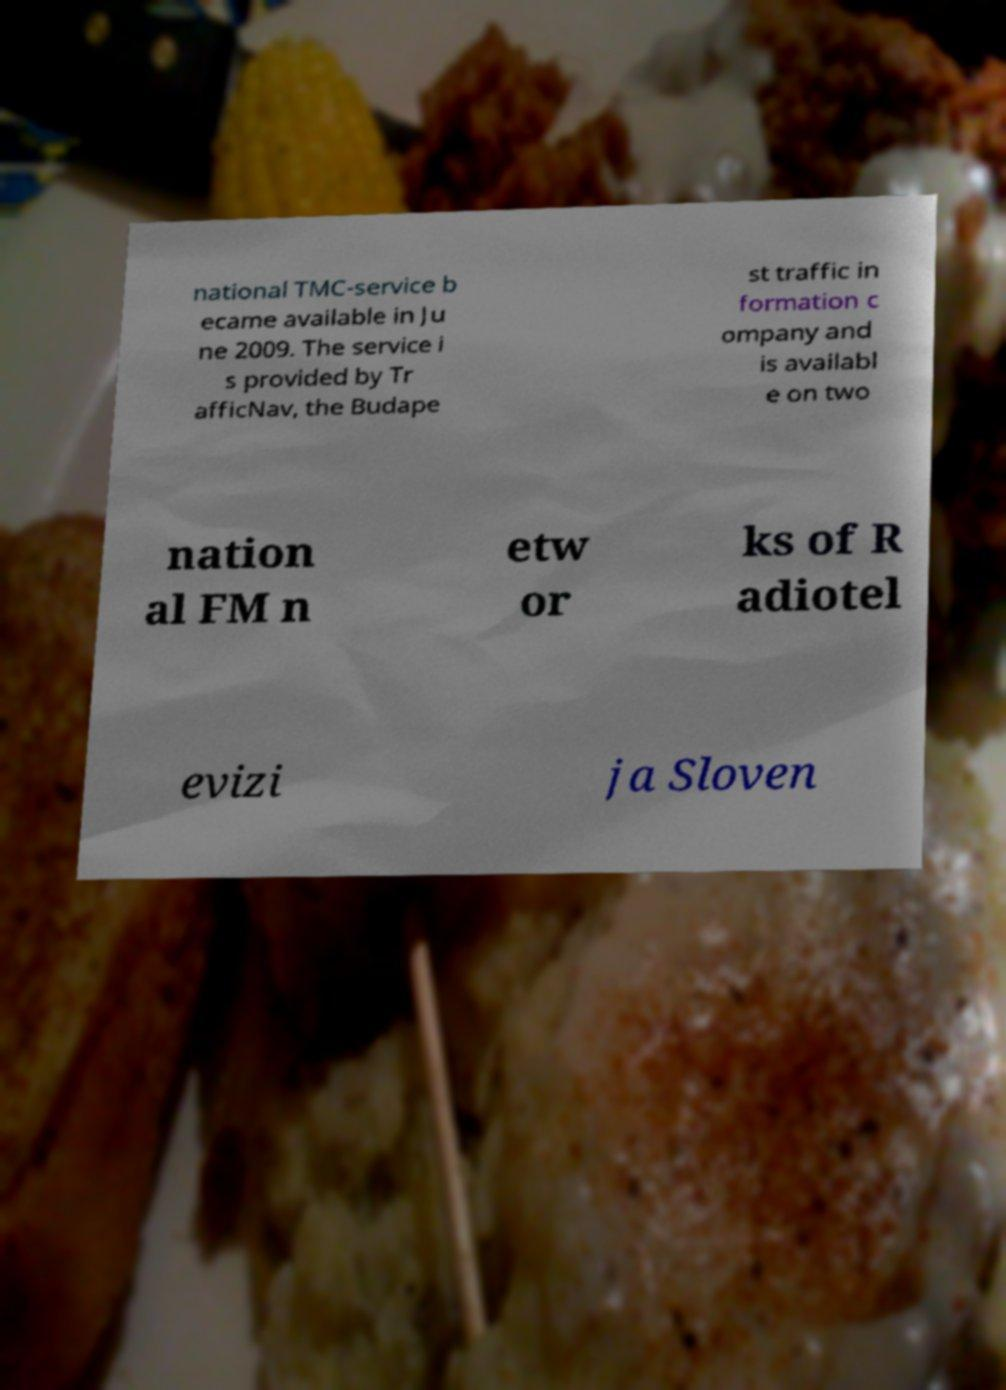Could you extract and type out the text from this image? national TMC-service b ecame available in Ju ne 2009. The service i s provided by Tr afficNav, the Budape st traffic in formation c ompany and is availabl e on two nation al FM n etw or ks of R adiotel evizi ja Sloven 